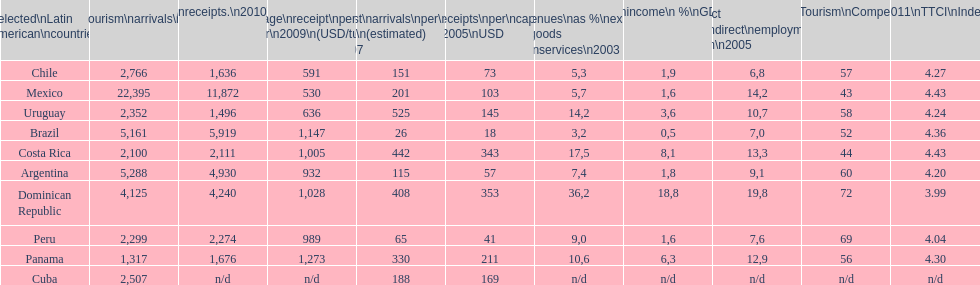What is the name of the country that had the most international tourism arrivals in 2010? Mexico. Can you parse all the data within this table? {'header': ['Selected\\nLatin American\\ncountries', 'Internl.\\ntourism\\narrivals\\n2010\\n(x 1000)', 'Internl.\\ntourism\\nreceipts.\\n2010\\n(USD\\n(x1000)', 'Average\\nreceipt\\nper visitor\\n2009\\n(USD/turista)', 'Tourist\\narrivals\\nper\\n1000 inhab\\n(estimated) \\n2007', 'Receipts\\nper\\ncapita \\n2005\\nUSD', 'Revenues\\nas\xa0%\\nexports of\\ngoods and\\nservices\\n2003', 'Tourism\\nincome\\n\xa0%\\nGDP\\n2003', '% Direct and\\nindirect\\nemployment\\nin tourism\\n2005', 'World\\nranking\\nTourism\\nCompetitiv.\\nTTCI\\n2011', '2011\\nTTCI\\nIndex'], 'rows': [['Chile', '2,766', '1,636', '591', '151', '73', '5,3', '1,9', '6,8', '57', '4.27'], ['Mexico', '22,395', '11,872', '530', '201', '103', '5,7', '1,6', '14,2', '43', '4.43'], ['Uruguay', '2,352', '1,496', '636', '525', '145', '14,2', '3,6', '10,7', '58', '4.24'], ['Brazil', '5,161', '5,919', '1,147', '26', '18', '3,2', '0,5', '7,0', '52', '4.36'], ['Costa Rica', '2,100', '2,111', '1,005', '442', '343', '17,5', '8,1', '13,3', '44', '4.43'], ['Argentina', '5,288', '4,930', '932', '115', '57', '7,4', '1,8', '9,1', '60', '4.20'], ['Dominican Republic', '4,125', '4,240', '1,028', '408', '353', '36,2', '18,8', '19,8', '72', '3.99'], ['Peru', '2,299', '2,274', '989', '65', '41', '9,0', '1,6', '7,6', '69', '4.04'], ['Panama', '1,317', '1,676', '1,273', '330', '211', '10,6', '6,3', '12,9', '56', '4.30'], ['Cuba', '2,507', 'n/d', 'n/d', '188', '169', 'n/d', 'n/d', 'n/d', 'n/d', 'n/d']]} 